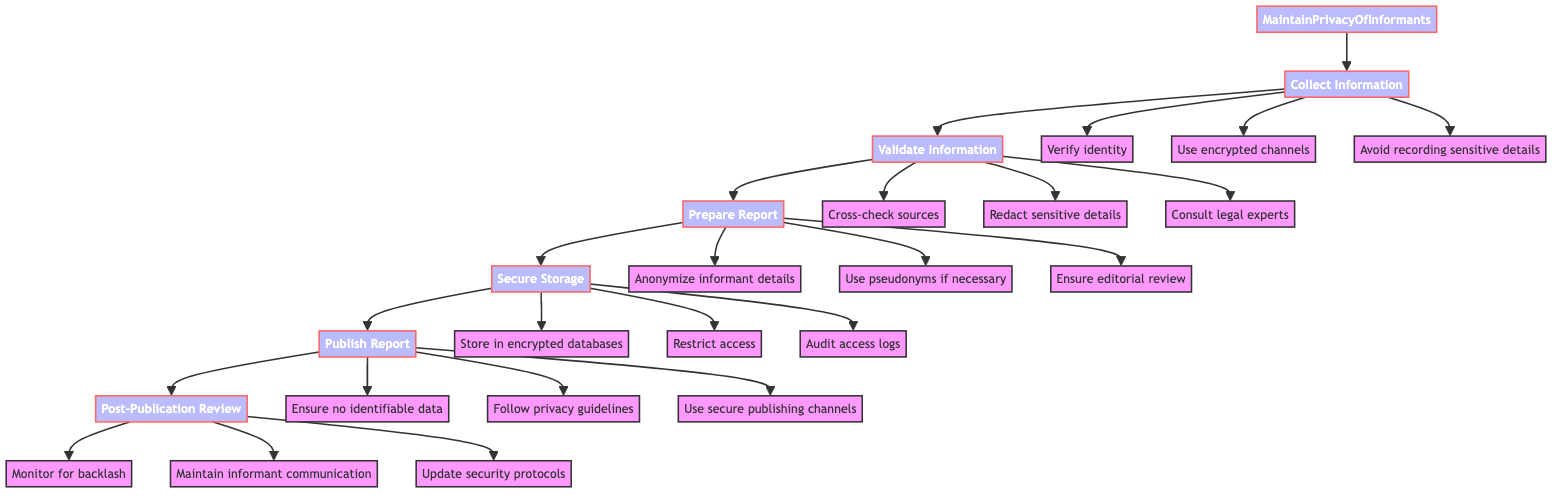What is the first step in maintaining privacy? The first step in the flowchart is "Collect Information," which is indicated as the initial node leading to subsequent steps.
Answer: Collect Information How many actions are listed under the "Prepare Report" step? Under the "Prepare Report" step, there are three actions outlined: "Anonymize informant details," "Use pseudonyms if necessary," and "Ensure full editorial review." Thus, the total count is three.
Answer: 3 Which step involves consulting legal experts? The action to "Consult legal experts" is found under the "Validate Information" step, as indicated by the arrows connecting this action to its respective step.
Answer: Validate Information What is required for storing notes according to the diagram? The "Secure Storage" step specifically states that notes should be "Stored in encrypted databases," highlighting a key requirement for maintaining privacy.
Answer: Stored in encrypted databases Which step comes after "Publish Report"? The step that follows "Publish Report" in the flowchart is "Post-Publication Review," as indicated by the directional flow of the diagram connecting these two nodes sequentially.
Answer: Post-Publication Review How many actions focus on communication during the "Post-Publication Review"? There are three actions listed under the "Post-Publication Review" step: "Monitor for backlash," "Maintain open communication with the informant," and "Update security protocols." Therefore, the total focusing on communication is one, which is "Maintain open communication with the informant."
Answer: 1 What ensures that the report is free of identifiable details? The action "Ensure no identifiable data is included" under the "Publish Report" step is specifically aimed at guaranteeing the anonymity of the informant.
Answer: Ensure no identifiable data is included What does the "Validate Information" step emphasize on preserving identity? This step emphasizes "Redact sensitive details that could reveal informant's identity" as a crucial action in preserving the identity of the informant during the validation process.
Answer: Redact sensitive details that could reveal informant's identity Which layer in the diagram includes actions related to confidentiality during communication? The "Collect Information" step contains actions specifically addressing confidentiality during communication, including "Use encrypted channels for communication."
Answer: Use encrypted channels for communication 